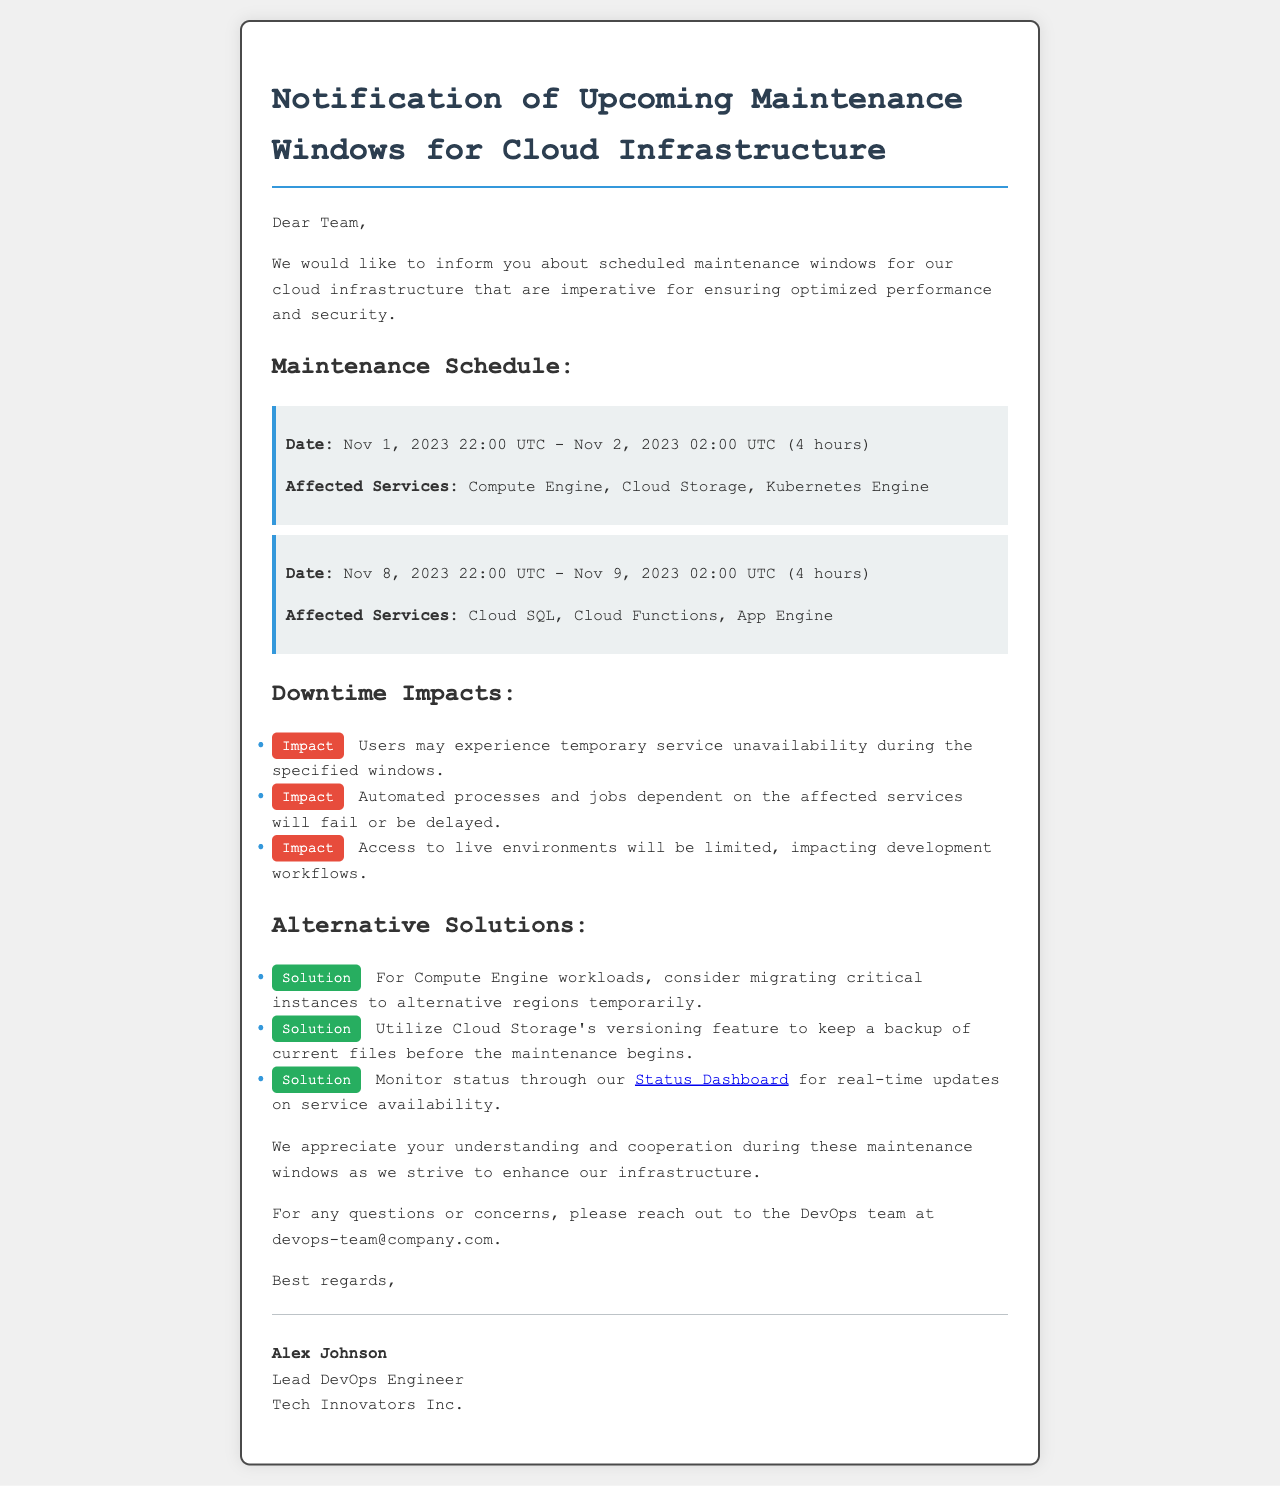What are the maintenance start dates? The document specifies the maintenance begins on "Nov 1, 2023" and again on "Nov 8, 2023."
Answer: Nov 1, 2023; Nov 8, 2023 How long will each maintenance window last? Each maintenance window is stated to last for "4 hours."
Answer: 4 hours Which services are affected during the first maintenance window? The affected services during the first window are listed as "Compute Engine, Cloud Storage, Kubernetes Engine."
Answer: Compute Engine, Cloud Storage, Kubernetes Engine What is one impact mentioned regarding users? An impact mentioned is that "Users may experience temporary service unavailability during the specified windows."
Answer: Temporary service unavailability What is one alternative solution proposed for critical instances? The document suggests "migrating critical instances to alternative regions temporarily" for dealing with downtime.
Answer: Migrating critical instances to alternative regions Who can be contacted for questions or concerns? The document indicates to reach out to the "DevOps team at devops-team@company.com."
Answer: DevOps team at devops-team@company.com What is the purpose of the maintenance windows? The letter states the purpose is "for ensuring optimized performance and security."
Answer: Optimized performance and security How many maintenance windows are scheduled in total? There are two maintenance windows scheduled as detailed in the document.
Answer: Two 